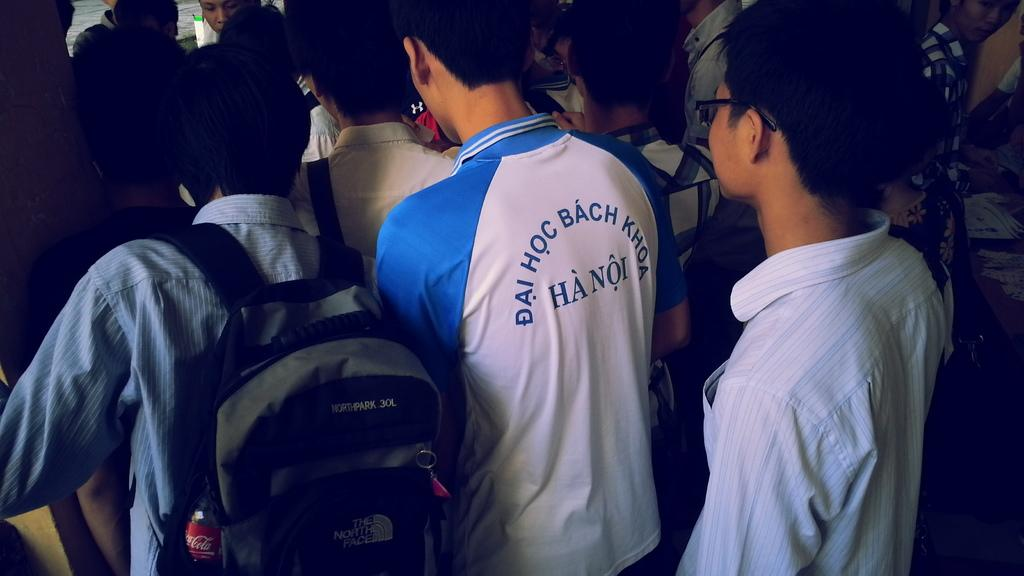<image>
Create a compact narrative representing the image presented. a few men standing and one with a Hanoi shirt on 